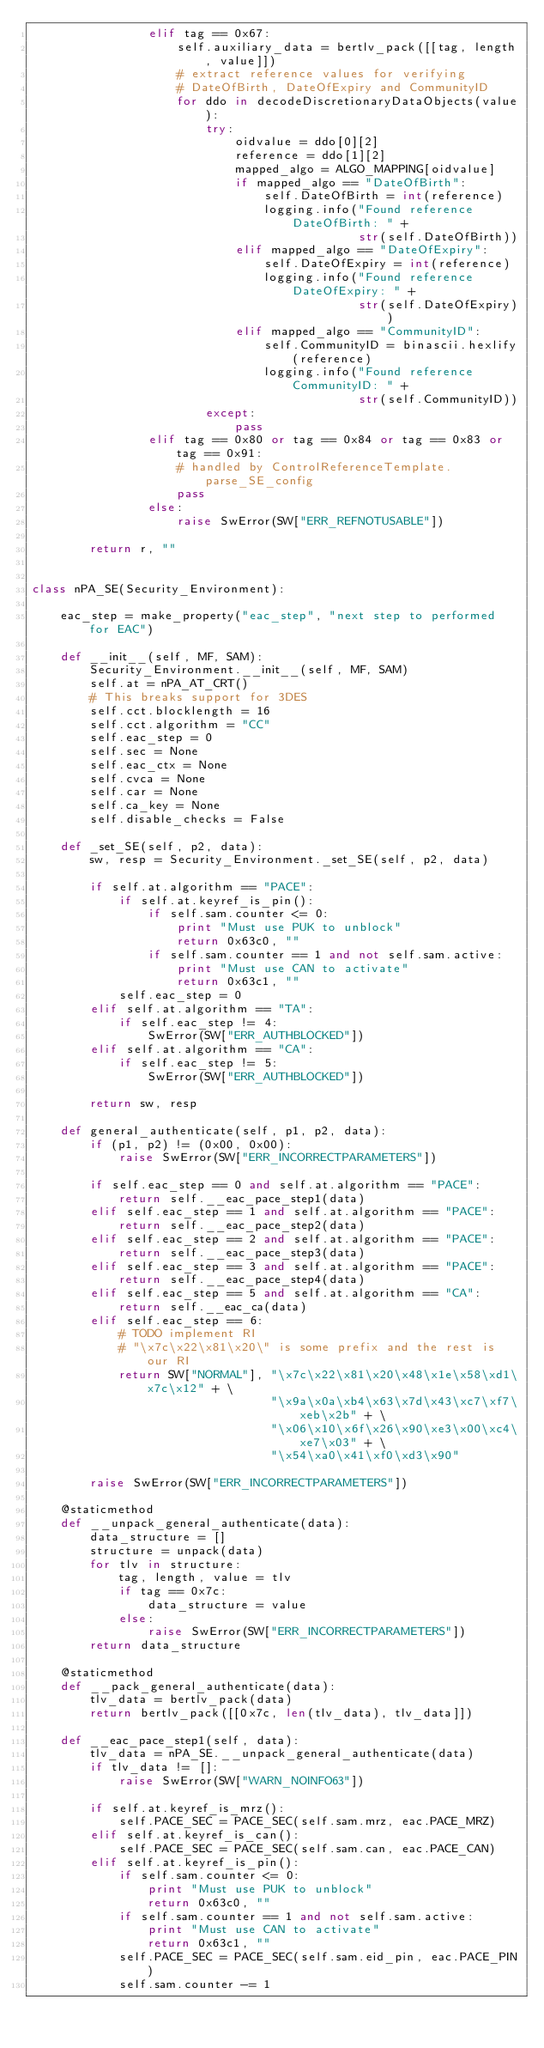Convert code to text. <code><loc_0><loc_0><loc_500><loc_500><_Python_>                elif tag == 0x67:
                    self.auxiliary_data = bertlv_pack([[tag, length, value]])
                    # extract reference values for verifying
                    # DateOfBirth, DateOfExpiry and CommunityID
                    for ddo in decodeDiscretionaryDataObjects(value):
                        try:
                            oidvalue = ddo[0][2]
                            reference = ddo[1][2]
                            mapped_algo = ALGO_MAPPING[oidvalue]
                            if mapped_algo == "DateOfBirth":
                                self.DateOfBirth = int(reference)
                                logging.info("Found reference DateOfBirth: " +
                                             str(self.DateOfBirth))
                            elif mapped_algo == "DateOfExpiry":
                                self.DateOfExpiry = int(reference)
                                logging.info("Found reference DateOfExpiry: " +
                                             str(self.DateOfExpiry))
                            elif mapped_algo == "CommunityID":
                                self.CommunityID = binascii.hexlify(reference)
                                logging.info("Found reference CommunityID: " +
                                             str(self.CommunityID))
                        except:
                            pass
                elif tag == 0x80 or tag == 0x84 or tag == 0x83 or tag == 0x91:
                    # handled by ControlReferenceTemplate.parse_SE_config
                    pass
                else:
                    raise SwError(SW["ERR_REFNOTUSABLE"])

        return r, ""


class nPA_SE(Security_Environment):

    eac_step = make_property("eac_step", "next step to performed for EAC")

    def __init__(self, MF, SAM):
        Security_Environment.__init__(self, MF, SAM)
        self.at = nPA_AT_CRT()
        # This breaks support for 3DES
        self.cct.blocklength = 16
        self.cct.algorithm = "CC"
        self.eac_step = 0
        self.sec = None
        self.eac_ctx = None
        self.cvca = None
        self.car = None
        self.ca_key = None
        self.disable_checks = False

    def _set_SE(self, p2, data):
        sw, resp = Security_Environment._set_SE(self, p2, data)

        if self.at.algorithm == "PACE":
            if self.at.keyref_is_pin():
                if self.sam.counter <= 0:
                    print "Must use PUK to unblock"
                    return 0x63c0, ""
                if self.sam.counter == 1 and not self.sam.active:
                    print "Must use CAN to activate"
                    return 0x63c1, ""
            self.eac_step = 0
        elif self.at.algorithm == "TA":
            if self.eac_step != 4:
                SwError(SW["ERR_AUTHBLOCKED"])
        elif self.at.algorithm == "CA":
            if self.eac_step != 5:
                SwError(SW["ERR_AUTHBLOCKED"])

        return sw, resp

    def general_authenticate(self, p1, p2, data):
        if (p1, p2) != (0x00, 0x00):
            raise SwError(SW["ERR_INCORRECTPARAMETERS"])

        if self.eac_step == 0 and self.at.algorithm == "PACE":
            return self.__eac_pace_step1(data)
        elif self.eac_step == 1 and self.at.algorithm == "PACE":
            return self.__eac_pace_step2(data)
        elif self.eac_step == 2 and self.at.algorithm == "PACE":
            return self.__eac_pace_step3(data)
        elif self.eac_step == 3 and self.at.algorithm == "PACE":
            return self.__eac_pace_step4(data)
        elif self.eac_step == 5 and self.at.algorithm == "CA":
            return self.__eac_ca(data)
        elif self.eac_step == 6:
            # TODO implement RI
            # "\x7c\x22\x81\x20\" is some prefix and the rest is our RI
            return SW["NORMAL"], "\x7c\x22\x81\x20\x48\x1e\x58\xd1\x7c\x12" + \
                                 "\x9a\x0a\xb4\x63\x7d\x43\xc7\xf7\xeb\x2b" + \
                                 "\x06\x10\x6f\x26\x90\xe3\x00\xc4\xe7\x03" + \
                                 "\x54\xa0\x41\xf0\xd3\x90"

        raise SwError(SW["ERR_INCORRECTPARAMETERS"])

    @staticmethod
    def __unpack_general_authenticate(data):
        data_structure = []
        structure = unpack(data)
        for tlv in structure:
            tag, length, value = tlv
            if tag == 0x7c:
                data_structure = value
            else:
                raise SwError(SW["ERR_INCORRECTPARAMETERS"])
        return data_structure

    @staticmethod
    def __pack_general_authenticate(data):
        tlv_data = bertlv_pack(data)
        return bertlv_pack([[0x7c, len(tlv_data), tlv_data]])

    def __eac_pace_step1(self, data):
        tlv_data = nPA_SE.__unpack_general_authenticate(data)
        if tlv_data != []:
            raise SwError(SW["WARN_NOINFO63"])

        if self.at.keyref_is_mrz():
            self.PACE_SEC = PACE_SEC(self.sam.mrz, eac.PACE_MRZ)
        elif self.at.keyref_is_can():
            self.PACE_SEC = PACE_SEC(self.sam.can, eac.PACE_CAN)
        elif self.at.keyref_is_pin():
            if self.sam.counter <= 0:
                print "Must use PUK to unblock"
                return 0x63c0, ""
            if self.sam.counter == 1 and not self.sam.active:
                print "Must use CAN to activate"
                return 0x63c1, ""
            self.PACE_SEC = PACE_SEC(self.sam.eid_pin, eac.PACE_PIN)
            self.sam.counter -= 1</code> 